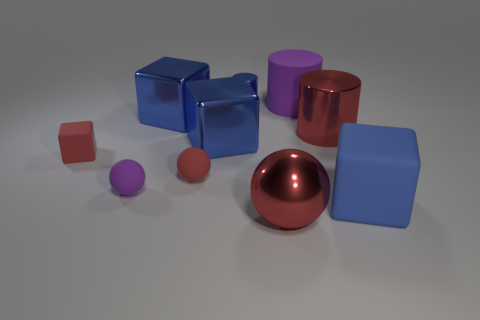What is the shape of the large matte object that is the same color as the tiny cylinder?
Provide a short and direct response. Cube. The rubber ball that is the same color as the rubber cylinder is what size?
Your answer should be very brief. Small. There is a large cube that is in front of the tiny red matte ball; is it the same color as the matte cylinder?
Offer a terse response. No. How many objects are matte cubes to the left of the metal ball or large blue cubes that are in front of the tiny block?
Provide a short and direct response. 2. How many matte objects are to the left of the metallic ball and behind the purple sphere?
Ensure brevity in your answer.  2. Is the small cylinder made of the same material as the large ball?
Give a very brief answer. Yes. There is a purple thing that is on the left side of the shiny cylinder that is behind the purple object behind the tiny red rubber block; what is its shape?
Give a very brief answer. Sphere. What is the material of the red object that is in front of the tiny cube and right of the small metallic cylinder?
Your answer should be compact. Metal. There is a big block that is behind the large blue shiny cube in front of the big red shiny object on the right side of the large purple matte cylinder; what is its color?
Provide a short and direct response. Blue. How many blue things are either small rubber objects or large rubber objects?
Keep it short and to the point. 1. 